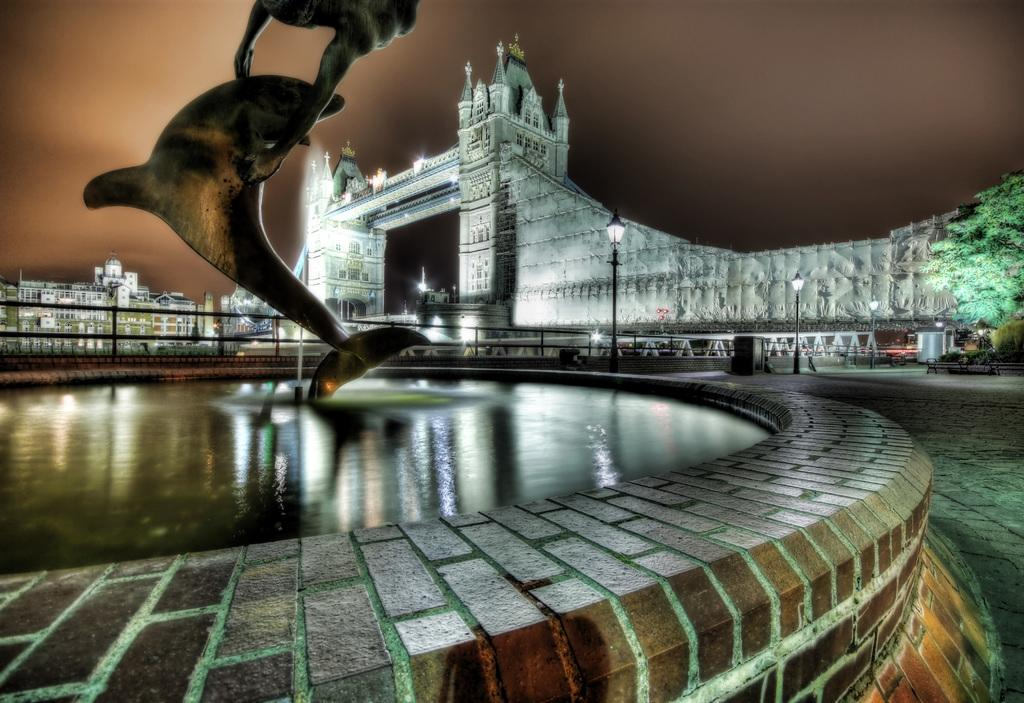What type of structure can be seen in the image? There is a bridge in the image. What type of vegetation is present in the image? There are trees in the image. What type of illumination is visible in the image? There are lights in the image. What type of support structures are present in the image? There are poles in the image. What type of natural feature is present in the image? There is water in the image. What type of man-made structures are present in the image? There are buildings in the image. What type of statue is present in the image? There is a statue of a dolphin in the image. What can be seen in the background of the image? The sky is visible in the background of the image. What type of sail can be seen on the earth in the image? There is no sail or earth present in the image. What type of harbor can be seen in the image? There is no harbor present in the image. 